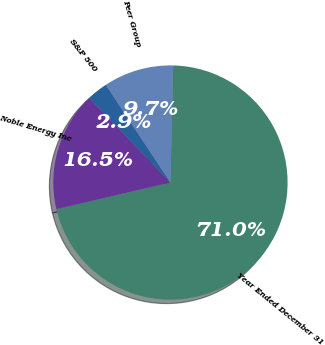<chart> <loc_0><loc_0><loc_500><loc_500><pie_chart><fcel>Year Ended December 31<fcel>Noble Energy Inc<fcel>S&P 500<fcel>Peer Group<nl><fcel>70.99%<fcel>16.48%<fcel>2.85%<fcel>9.67%<nl></chart> 